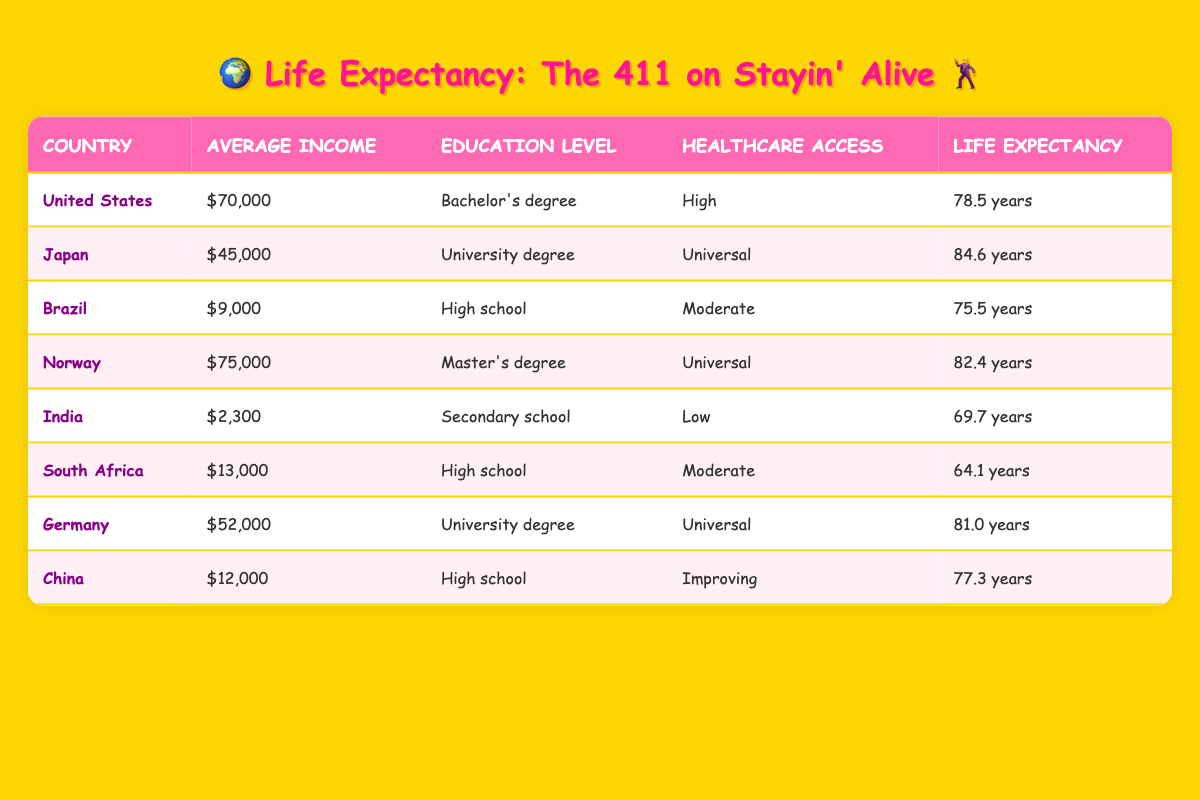What is the life expectancy of Japan? The table shows that Japan has a life expectancy of 84.6 years, as found directly in the relevant row for Japan.
Answer: 84.6 Which country has the lowest average income? Looking at the table, India has the lowest average income of 2,300, listed in the appropriate row for India.
Answer: India What is the average life expectancy of countries with high healthcare access? The countries with high healthcare access are the United States, Norway, Germany, and Japan. Their life expectancies are 78.5, 82.4, 81.0, and 84.6, respectively. Adding these together gives 324.5, and dividing by 4 yields an average of 81.125.
Answer: 81.125 Is South Africa's average income higher than Brazil's? According to the table, South Africa has an average income of 13,000, while Brazil has an average income of 9,000. Since 13,000 is greater than 9,000, the statement is true.
Answer: Yes Which country has both the highest income and university-level education? Norway has the highest income at 75,000 and a Master's degree listed in its education level. No other country has a higher income with university-level education.
Answer: Norway What are the average life expectancies for countries with secondary education and low healthcare access? In the table, India has a life expectancy of 69.7, and there are no other countries that fit this criteria based on secondary education and low healthcare access. The average life expectancy is therefore 69.7.
Answer: 69.7 How many countries listed have a life expectancy above 80 years? Looking through the table, the countries with life expectancies above 80 years are Japan (84.6), Norway (82.4), and Germany (81.0), totaling three countries.
Answer: 3 What is the difference in life expectancy between the country with the highest income and the country with the lowest? The United States has the highest average income of 70,000 with a life expectancy of 78.5, and India has the lowest average income of 2,300 with a life expectancy of 69.7. Thus, the difference is 78.5 - 69.7 = 8.8 years.
Answer: 8.8 